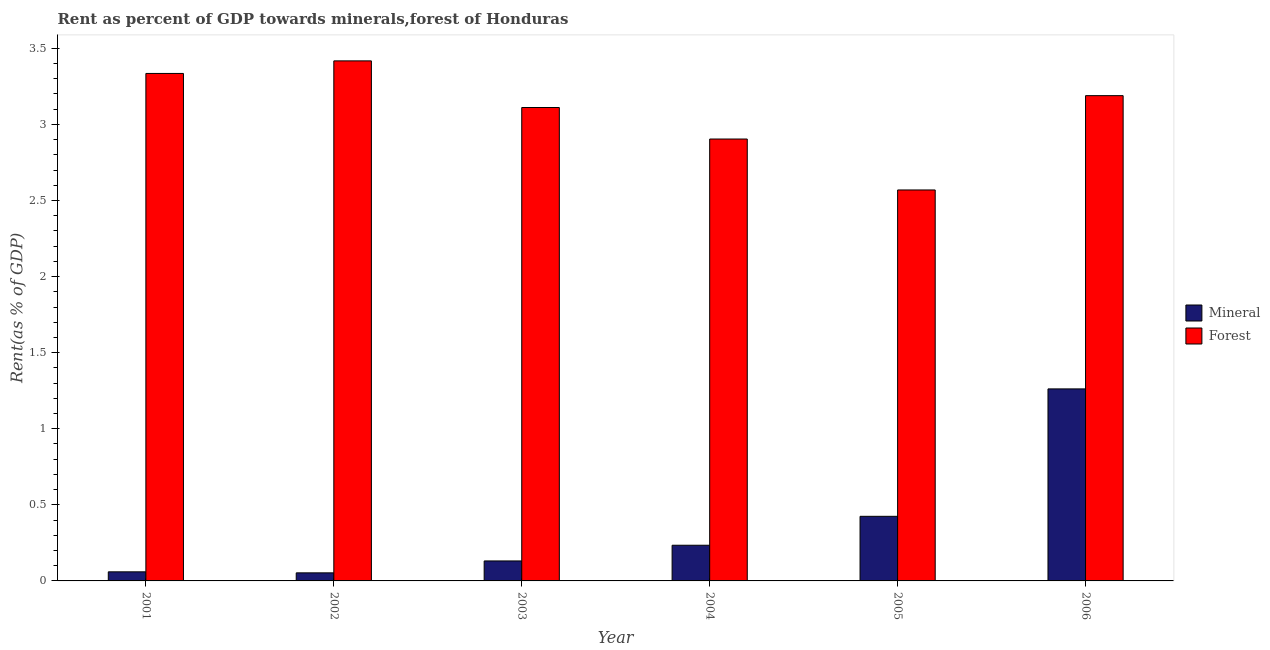How many groups of bars are there?
Your answer should be very brief. 6. Are the number of bars on each tick of the X-axis equal?
Your answer should be very brief. Yes. What is the forest rent in 2003?
Offer a very short reply. 3.11. Across all years, what is the maximum mineral rent?
Your answer should be compact. 1.26. Across all years, what is the minimum mineral rent?
Your response must be concise. 0.05. In which year was the mineral rent maximum?
Provide a succinct answer. 2006. What is the total mineral rent in the graph?
Make the answer very short. 2.16. What is the difference between the forest rent in 2005 and that in 2006?
Give a very brief answer. -0.62. What is the difference between the mineral rent in 2001 and the forest rent in 2002?
Your response must be concise. 0.01. What is the average mineral rent per year?
Offer a very short reply. 0.36. In the year 2006, what is the difference between the forest rent and mineral rent?
Keep it short and to the point. 0. What is the ratio of the forest rent in 2002 to that in 2006?
Give a very brief answer. 1.07. Is the mineral rent in 2003 less than that in 2006?
Keep it short and to the point. Yes. Is the difference between the mineral rent in 2004 and 2005 greater than the difference between the forest rent in 2004 and 2005?
Provide a short and direct response. No. What is the difference between the highest and the second highest forest rent?
Offer a terse response. 0.08. What is the difference between the highest and the lowest mineral rent?
Offer a terse response. 1.21. In how many years, is the mineral rent greater than the average mineral rent taken over all years?
Provide a short and direct response. 2. Is the sum of the forest rent in 2002 and 2006 greater than the maximum mineral rent across all years?
Your answer should be very brief. Yes. What does the 2nd bar from the left in 2002 represents?
Your answer should be compact. Forest. What does the 1st bar from the right in 2005 represents?
Make the answer very short. Forest. How many bars are there?
Provide a short and direct response. 12. Are all the bars in the graph horizontal?
Give a very brief answer. No. What is the difference between two consecutive major ticks on the Y-axis?
Offer a terse response. 0.5. Are the values on the major ticks of Y-axis written in scientific E-notation?
Give a very brief answer. No. Does the graph contain any zero values?
Ensure brevity in your answer.  No. How many legend labels are there?
Provide a short and direct response. 2. What is the title of the graph?
Keep it short and to the point. Rent as percent of GDP towards minerals,forest of Honduras. What is the label or title of the X-axis?
Your answer should be compact. Year. What is the label or title of the Y-axis?
Give a very brief answer. Rent(as % of GDP). What is the Rent(as % of GDP) of Mineral in 2001?
Provide a succinct answer. 0.06. What is the Rent(as % of GDP) of Forest in 2001?
Your answer should be compact. 3.33. What is the Rent(as % of GDP) of Mineral in 2002?
Give a very brief answer. 0.05. What is the Rent(as % of GDP) in Forest in 2002?
Offer a terse response. 3.42. What is the Rent(as % of GDP) of Mineral in 2003?
Provide a succinct answer. 0.13. What is the Rent(as % of GDP) of Forest in 2003?
Your answer should be compact. 3.11. What is the Rent(as % of GDP) of Mineral in 2004?
Your answer should be very brief. 0.23. What is the Rent(as % of GDP) of Forest in 2004?
Give a very brief answer. 2.9. What is the Rent(as % of GDP) of Mineral in 2005?
Provide a succinct answer. 0.42. What is the Rent(as % of GDP) in Forest in 2005?
Provide a short and direct response. 2.57. What is the Rent(as % of GDP) in Mineral in 2006?
Ensure brevity in your answer.  1.26. What is the Rent(as % of GDP) in Forest in 2006?
Provide a short and direct response. 3.19. Across all years, what is the maximum Rent(as % of GDP) in Mineral?
Provide a succinct answer. 1.26. Across all years, what is the maximum Rent(as % of GDP) of Forest?
Give a very brief answer. 3.42. Across all years, what is the minimum Rent(as % of GDP) in Mineral?
Offer a terse response. 0.05. Across all years, what is the minimum Rent(as % of GDP) in Forest?
Give a very brief answer. 2.57. What is the total Rent(as % of GDP) in Mineral in the graph?
Provide a succinct answer. 2.16. What is the total Rent(as % of GDP) of Forest in the graph?
Give a very brief answer. 18.52. What is the difference between the Rent(as % of GDP) in Mineral in 2001 and that in 2002?
Keep it short and to the point. 0.01. What is the difference between the Rent(as % of GDP) of Forest in 2001 and that in 2002?
Your answer should be compact. -0.08. What is the difference between the Rent(as % of GDP) of Mineral in 2001 and that in 2003?
Offer a very short reply. -0.07. What is the difference between the Rent(as % of GDP) of Forest in 2001 and that in 2003?
Keep it short and to the point. 0.22. What is the difference between the Rent(as % of GDP) of Mineral in 2001 and that in 2004?
Your answer should be very brief. -0.17. What is the difference between the Rent(as % of GDP) in Forest in 2001 and that in 2004?
Provide a succinct answer. 0.43. What is the difference between the Rent(as % of GDP) in Mineral in 2001 and that in 2005?
Make the answer very short. -0.36. What is the difference between the Rent(as % of GDP) of Forest in 2001 and that in 2005?
Your answer should be very brief. 0.77. What is the difference between the Rent(as % of GDP) of Mineral in 2001 and that in 2006?
Provide a succinct answer. -1.2. What is the difference between the Rent(as % of GDP) of Forest in 2001 and that in 2006?
Keep it short and to the point. 0.15. What is the difference between the Rent(as % of GDP) of Mineral in 2002 and that in 2003?
Your response must be concise. -0.08. What is the difference between the Rent(as % of GDP) of Forest in 2002 and that in 2003?
Your answer should be compact. 0.31. What is the difference between the Rent(as % of GDP) of Mineral in 2002 and that in 2004?
Your answer should be very brief. -0.18. What is the difference between the Rent(as % of GDP) in Forest in 2002 and that in 2004?
Give a very brief answer. 0.51. What is the difference between the Rent(as % of GDP) in Mineral in 2002 and that in 2005?
Make the answer very short. -0.37. What is the difference between the Rent(as % of GDP) in Forest in 2002 and that in 2005?
Give a very brief answer. 0.85. What is the difference between the Rent(as % of GDP) in Mineral in 2002 and that in 2006?
Your response must be concise. -1.21. What is the difference between the Rent(as % of GDP) of Forest in 2002 and that in 2006?
Provide a succinct answer. 0.23. What is the difference between the Rent(as % of GDP) of Mineral in 2003 and that in 2004?
Keep it short and to the point. -0.1. What is the difference between the Rent(as % of GDP) of Forest in 2003 and that in 2004?
Provide a succinct answer. 0.21. What is the difference between the Rent(as % of GDP) in Mineral in 2003 and that in 2005?
Offer a very short reply. -0.29. What is the difference between the Rent(as % of GDP) in Forest in 2003 and that in 2005?
Offer a very short reply. 0.54. What is the difference between the Rent(as % of GDP) in Mineral in 2003 and that in 2006?
Make the answer very short. -1.13. What is the difference between the Rent(as % of GDP) in Forest in 2003 and that in 2006?
Provide a short and direct response. -0.08. What is the difference between the Rent(as % of GDP) of Mineral in 2004 and that in 2005?
Ensure brevity in your answer.  -0.19. What is the difference between the Rent(as % of GDP) in Forest in 2004 and that in 2005?
Your response must be concise. 0.33. What is the difference between the Rent(as % of GDP) in Mineral in 2004 and that in 2006?
Ensure brevity in your answer.  -1.03. What is the difference between the Rent(as % of GDP) in Forest in 2004 and that in 2006?
Provide a short and direct response. -0.28. What is the difference between the Rent(as % of GDP) in Mineral in 2005 and that in 2006?
Your answer should be compact. -0.84. What is the difference between the Rent(as % of GDP) in Forest in 2005 and that in 2006?
Make the answer very short. -0.62. What is the difference between the Rent(as % of GDP) in Mineral in 2001 and the Rent(as % of GDP) in Forest in 2002?
Provide a succinct answer. -3.36. What is the difference between the Rent(as % of GDP) of Mineral in 2001 and the Rent(as % of GDP) of Forest in 2003?
Your answer should be compact. -3.05. What is the difference between the Rent(as % of GDP) of Mineral in 2001 and the Rent(as % of GDP) of Forest in 2004?
Provide a succinct answer. -2.84. What is the difference between the Rent(as % of GDP) in Mineral in 2001 and the Rent(as % of GDP) in Forest in 2005?
Give a very brief answer. -2.51. What is the difference between the Rent(as % of GDP) of Mineral in 2001 and the Rent(as % of GDP) of Forest in 2006?
Give a very brief answer. -3.13. What is the difference between the Rent(as % of GDP) of Mineral in 2002 and the Rent(as % of GDP) of Forest in 2003?
Make the answer very short. -3.06. What is the difference between the Rent(as % of GDP) of Mineral in 2002 and the Rent(as % of GDP) of Forest in 2004?
Provide a succinct answer. -2.85. What is the difference between the Rent(as % of GDP) of Mineral in 2002 and the Rent(as % of GDP) of Forest in 2005?
Your answer should be very brief. -2.52. What is the difference between the Rent(as % of GDP) in Mineral in 2002 and the Rent(as % of GDP) in Forest in 2006?
Your answer should be compact. -3.14. What is the difference between the Rent(as % of GDP) in Mineral in 2003 and the Rent(as % of GDP) in Forest in 2004?
Keep it short and to the point. -2.77. What is the difference between the Rent(as % of GDP) of Mineral in 2003 and the Rent(as % of GDP) of Forest in 2005?
Your answer should be very brief. -2.44. What is the difference between the Rent(as % of GDP) in Mineral in 2003 and the Rent(as % of GDP) in Forest in 2006?
Keep it short and to the point. -3.06. What is the difference between the Rent(as % of GDP) of Mineral in 2004 and the Rent(as % of GDP) of Forest in 2005?
Keep it short and to the point. -2.33. What is the difference between the Rent(as % of GDP) in Mineral in 2004 and the Rent(as % of GDP) in Forest in 2006?
Your answer should be compact. -2.95. What is the difference between the Rent(as % of GDP) in Mineral in 2005 and the Rent(as % of GDP) in Forest in 2006?
Your response must be concise. -2.76. What is the average Rent(as % of GDP) in Mineral per year?
Your answer should be compact. 0.36. What is the average Rent(as % of GDP) of Forest per year?
Offer a terse response. 3.09. In the year 2001, what is the difference between the Rent(as % of GDP) in Mineral and Rent(as % of GDP) in Forest?
Your answer should be very brief. -3.27. In the year 2002, what is the difference between the Rent(as % of GDP) of Mineral and Rent(as % of GDP) of Forest?
Ensure brevity in your answer.  -3.36. In the year 2003, what is the difference between the Rent(as % of GDP) of Mineral and Rent(as % of GDP) of Forest?
Make the answer very short. -2.98. In the year 2004, what is the difference between the Rent(as % of GDP) in Mineral and Rent(as % of GDP) in Forest?
Your response must be concise. -2.67. In the year 2005, what is the difference between the Rent(as % of GDP) in Mineral and Rent(as % of GDP) in Forest?
Give a very brief answer. -2.14. In the year 2006, what is the difference between the Rent(as % of GDP) in Mineral and Rent(as % of GDP) in Forest?
Your response must be concise. -1.93. What is the ratio of the Rent(as % of GDP) of Mineral in 2001 to that in 2002?
Your answer should be compact. 1.13. What is the ratio of the Rent(as % of GDP) in Forest in 2001 to that in 2002?
Make the answer very short. 0.98. What is the ratio of the Rent(as % of GDP) of Mineral in 2001 to that in 2003?
Keep it short and to the point. 0.45. What is the ratio of the Rent(as % of GDP) of Forest in 2001 to that in 2003?
Offer a very short reply. 1.07. What is the ratio of the Rent(as % of GDP) in Mineral in 2001 to that in 2004?
Provide a short and direct response. 0.25. What is the ratio of the Rent(as % of GDP) of Forest in 2001 to that in 2004?
Your answer should be compact. 1.15. What is the ratio of the Rent(as % of GDP) of Mineral in 2001 to that in 2005?
Provide a short and direct response. 0.14. What is the ratio of the Rent(as % of GDP) in Forest in 2001 to that in 2005?
Your response must be concise. 1.3. What is the ratio of the Rent(as % of GDP) of Mineral in 2001 to that in 2006?
Make the answer very short. 0.05. What is the ratio of the Rent(as % of GDP) in Forest in 2001 to that in 2006?
Ensure brevity in your answer.  1.05. What is the ratio of the Rent(as % of GDP) in Mineral in 2002 to that in 2003?
Your answer should be very brief. 0.4. What is the ratio of the Rent(as % of GDP) in Forest in 2002 to that in 2003?
Give a very brief answer. 1.1. What is the ratio of the Rent(as % of GDP) of Mineral in 2002 to that in 2004?
Provide a succinct answer. 0.23. What is the ratio of the Rent(as % of GDP) of Forest in 2002 to that in 2004?
Ensure brevity in your answer.  1.18. What is the ratio of the Rent(as % of GDP) of Mineral in 2002 to that in 2005?
Ensure brevity in your answer.  0.12. What is the ratio of the Rent(as % of GDP) of Forest in 2002 to that in 2005?
Ensure brevity in your answer.  1.33. What is the ratio of the Rent(as % of GDP) in Mineral in 2002 to that in 2006?
Make the answer very short. 0.04. What is the ratio of the Rent(as % of GDP) of Forest in 2002 to that in 2006?
Your response must be concise. 1.07. What is the ratio of the Rent(as % of GDP) in Mineral in 2003 to that in 2004?
Offer a terse response. 0.56. What is the ratio of the Rent(as % of GDP) in Forest in 2003 to that in 2004?
Your answer should be very brief. 1.07. What is the ratio of the Rent(as % of GDP) in Mineral in 2003 to that in 2005?
Keep it short and to the point. 0.31. What is the ratio of the Rent(as % of GDP) in Forest in 2003 to that in 2005?
Ensure brevity in your answer.  1.21. What is the ratio of the Rent(as % of GDP) of Mineral in 2003 to that in 2006?
Provide a short and direct response. 0.1. What is the ratio of the Rent(as % of GDP) of Forest in 2003 to that in 2006?
Keep it short and to the point. 0.98. What is the ratio of the Rent(as % of GDP) in Mineral in 2004 to that in 2005?
Provide a short and direct response. 0.55. What is the ratio of the Rent(as % of GDP) of Forest in 2004 to that in 2005?
Your answer should be compact. 1.13. What is the ratio of the Rent(as % of GDP) in Mineral in 2004 to that in 2006?
Your answer should be very brief. 0.19. What is the ratio of the Rent(as % of GDP) in Forest in 2004 to that in 2006?
Offer a very short reply. 0.91. What is the ratio of the Rent(as % of GDP) of Mineral in 2005 to that in 2006?
Provide a short and direct response. 0.34. What is the ratio of the Rent(as % of GDP) in Forest in 2005 to that in 2006?
Keep it short and to the point. 0.81. What is the difference between the highest and the second highest Rent(as % of GDP) of Mineral?
Keep it short and to the point. 0.84. What is the difference between the highest and the second highest Rent(as % of GDP) of Forest?
Offer a very short reply. 0.08. What is the difference between the highest and the lowest Rent(as % of GDP) of Mineral?
Provide a short and direct response. 1.21. What is the difference between the highest and the lowest Rent(as % of GDP) of Forest?
Provide a succinct answer. 0.85. 